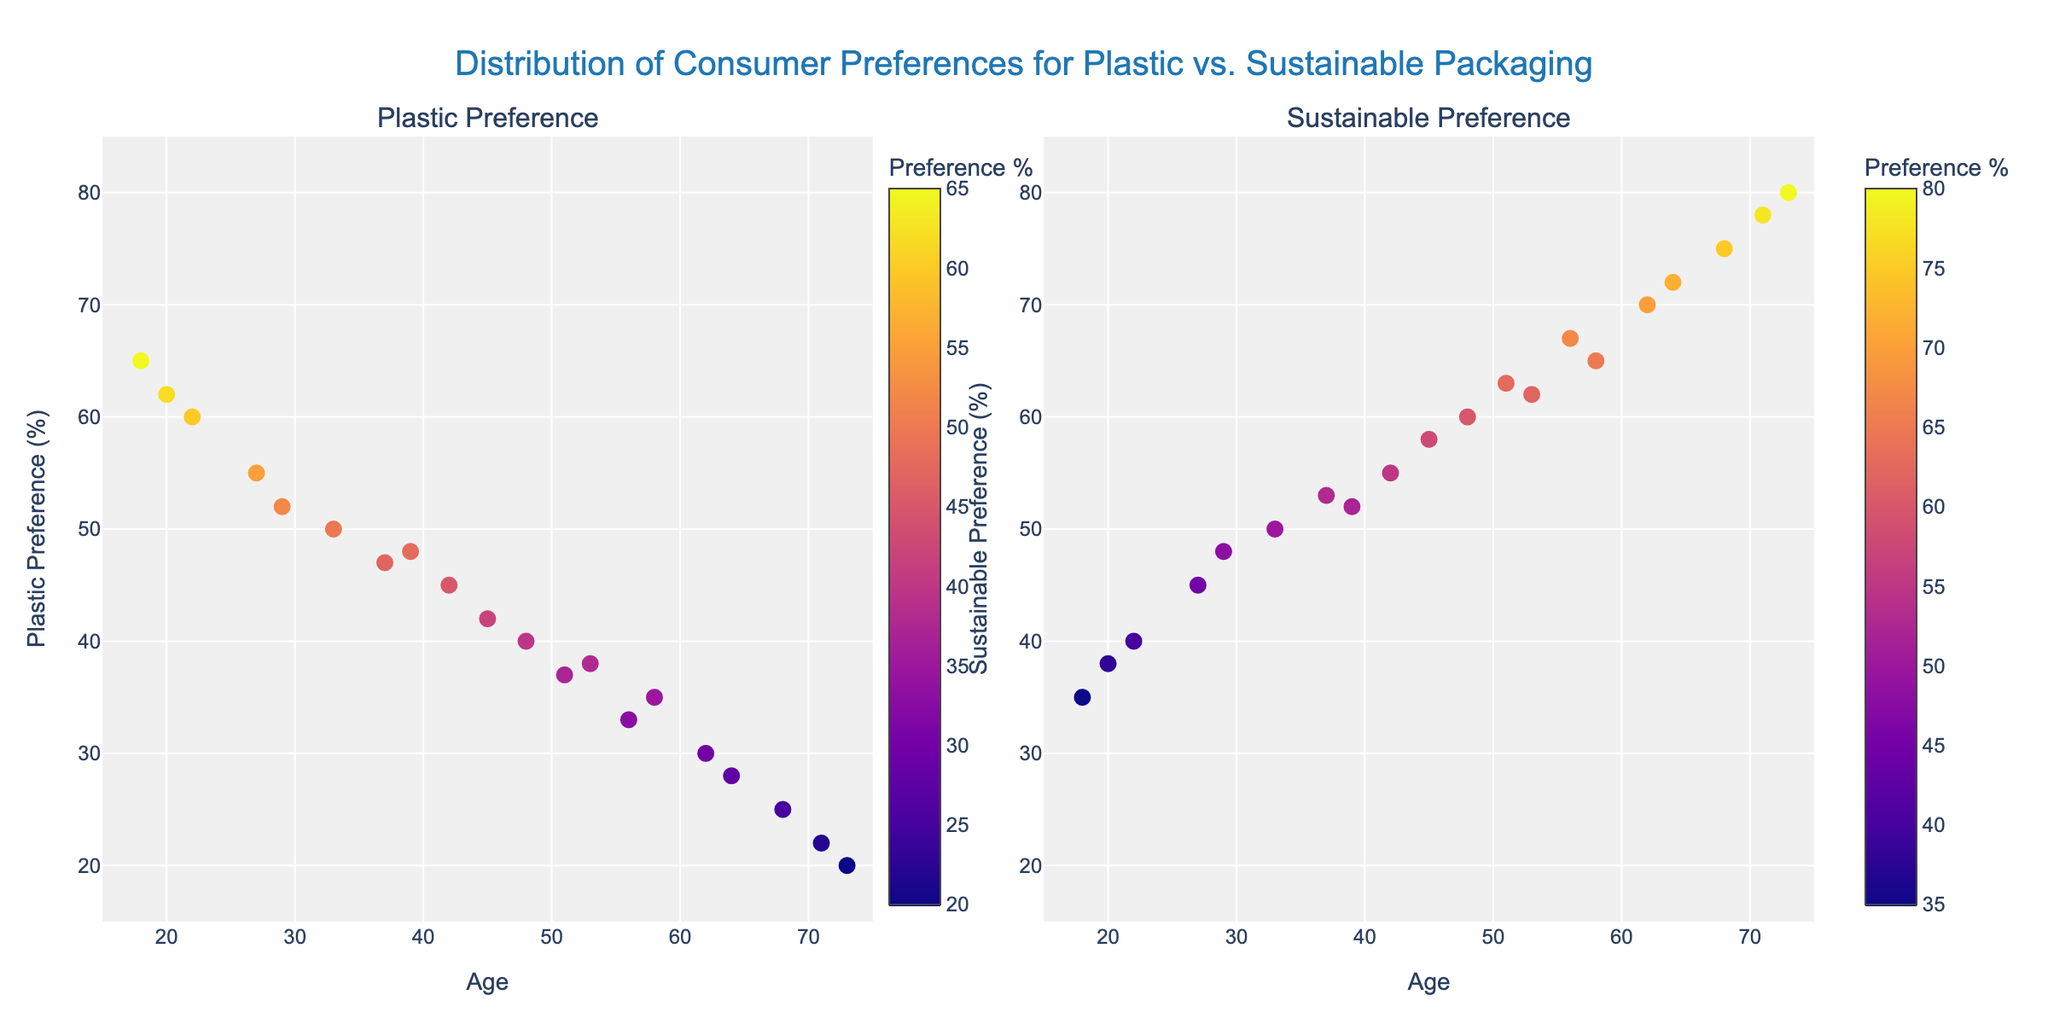What is the title of the figure? The title is located at the top center of the figure and usually describes the overall content. In this case, it reads "Distribution of Consumer Preferences for Plastic vs. Sustainable Packaging".
Answer: Distribution of Consumer Preferences for Plastic vs. Sustainable Packaging What does the y-axis represent in the left subplot? The y-axis in the left subplot shows the "Plastic Preference (%)", indicating the percentage of consumers who prefer plastic packaging.
Answer: Plastic Preference (%) How many data points are there in the 18-24 age group for plastic preference? By looking at the left subplot, we identify the data points with hover text showing the age group "18-24". There are three such points.
Answer: Three What is the age range represented in the figure? The x-axes in both subplots extend from 15 to 75, indicating this as the range of ages represented in the figure.
Answer: 15 to 75 What is the general trend in preferences for sustainable packaging as age increases? By examining the right subplot, we notice the y-values (Sustainable Preference) generally increase as age (x-axis) increases. This shows a positive correlation between age and preference for sustainable packaging.
Answer: Increases with age What are the plastic and sustainable preferences for a 45-year-old? Locate the data point closest to age 45 in both subplots. The plastic preference is near 42%, and the sustainable preference is around 58%.
Answer: 42% for plastic, 58% for sustainable In which age group is the preference for sustainable packaging equal to the preference for plastic packaging? Look at the points where the y-values are equal in both subplots. The age group where this happens is 25-34 (around age 33).
Answer: 25-34 What is the range of sustainable preferences for the 55-64 age group? Identify the data points corresponding to the 55-64 age group in the right subplot. The preferences range from 65% to 72%.
Answer: 65% to 72% Which subplot shows a higher variability in preferences, plastic or sustainable? Check the spread of points in the y-direction for both subplots. The left subplot (Plastic Preference) shows a wider spread compared to the right subplot (Sustainable Preference).
Answer: Plastic Preference How do the preferences for plastic and sustainable packaging compare among the eldest group (65+)? Locate the oldest age group (65+) in both subplots. Their preferences are around 20-25% for plastic and 75-80% for sustainable, indicating a strong preference for sustainable packaging.
Answer: Preference for sustainable is much higher 